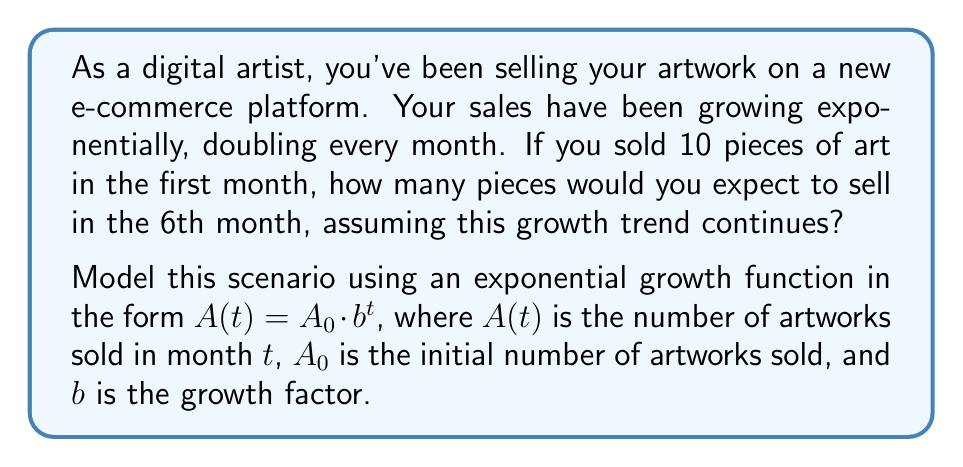Provide a solution to this math problem. To solve this problem, we'll use the exponential growth model:

$A(t) = A_0 \cdot b^t$

Where:
$A(t)$ = number of artworks sold in month $t$
$A_0$ = initial number of artworks sold (10 in this case)
$b$ = growth factor
$t$ = time in months

Step 1: Determine the growth factor $b$
We're told that sales double every month, so:
$b = 2$

Step 2: Set up the equation
$A(t) = 10 \cdot 2^t$

Step 3: Calculate for the 6th month (t = 5, since we start at t = 0)
$A(5) = 10 \cdot 2^5$

Step 4: Solve
$A(5) = 10 \cdot 32 = 320$

Therefore, in the 6th month (t = 5), you would expect to sell 320 pieces of artwork.
Answer: 320 pieces of artwork 